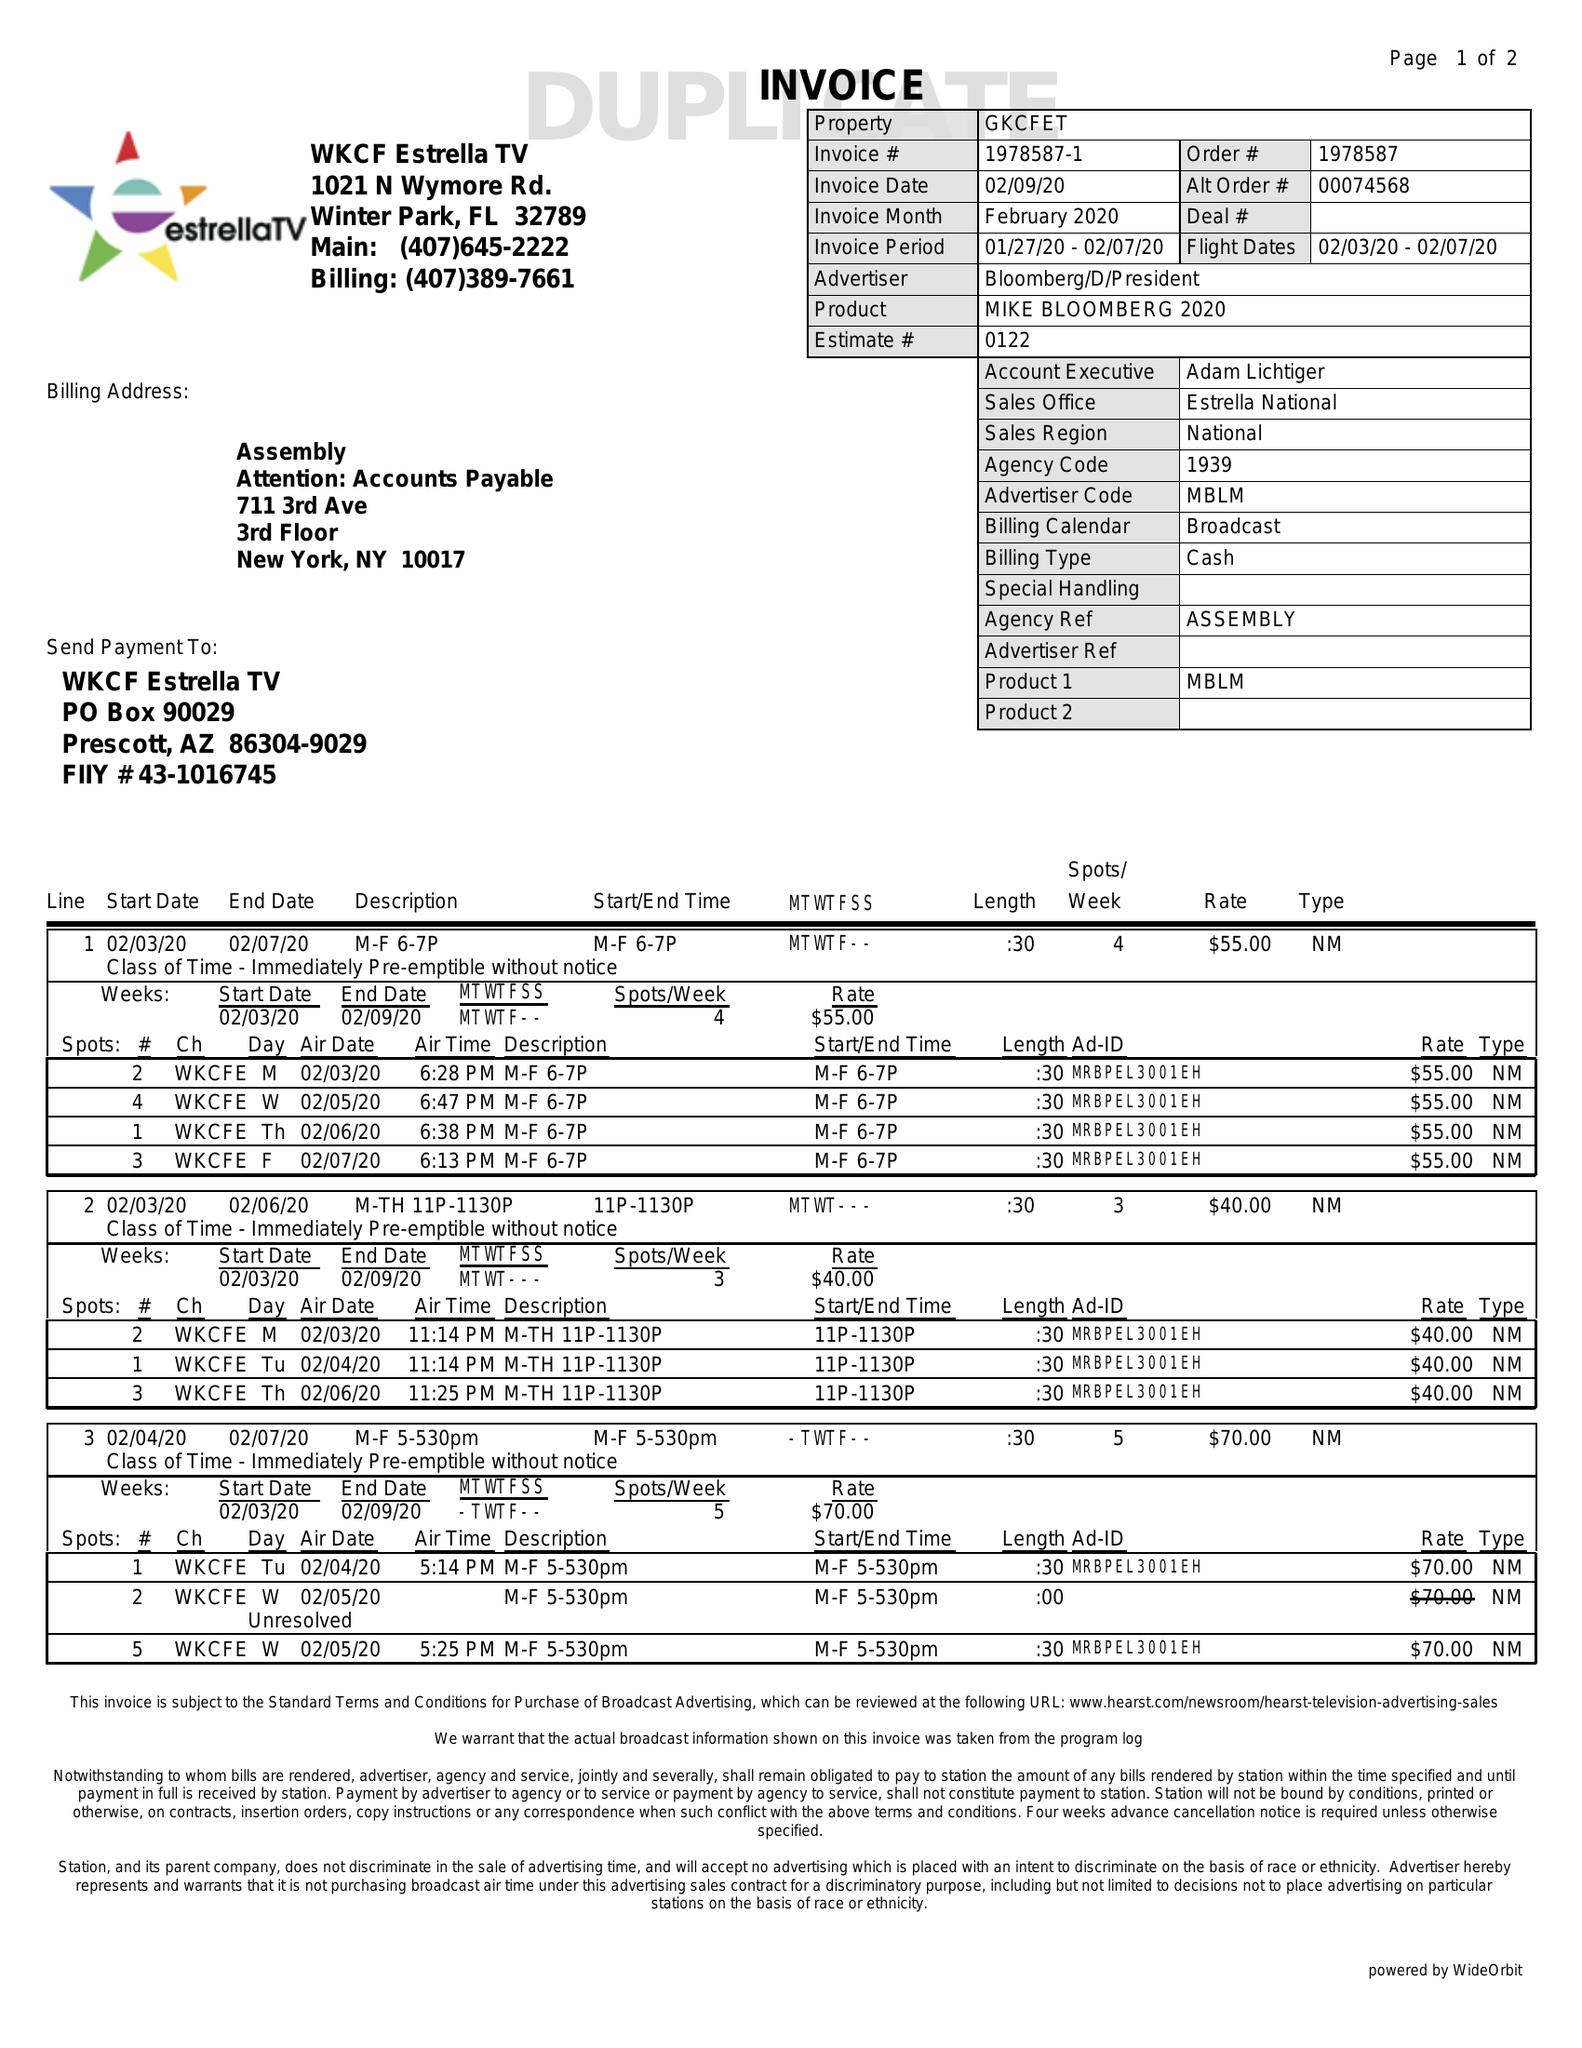What is the value for the flight_from?
Answer the question using a single word or phrase. 02/03/20 